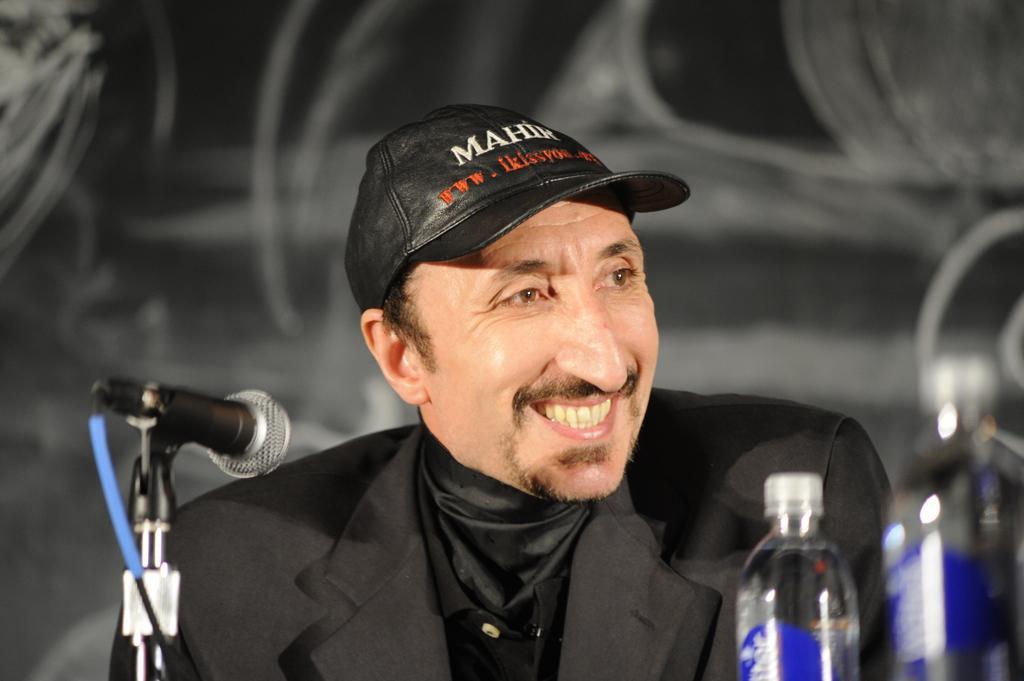Describe this image in one or two sentences. As we can see in the image there is a man sitting over here and there is a mic and bottle. 